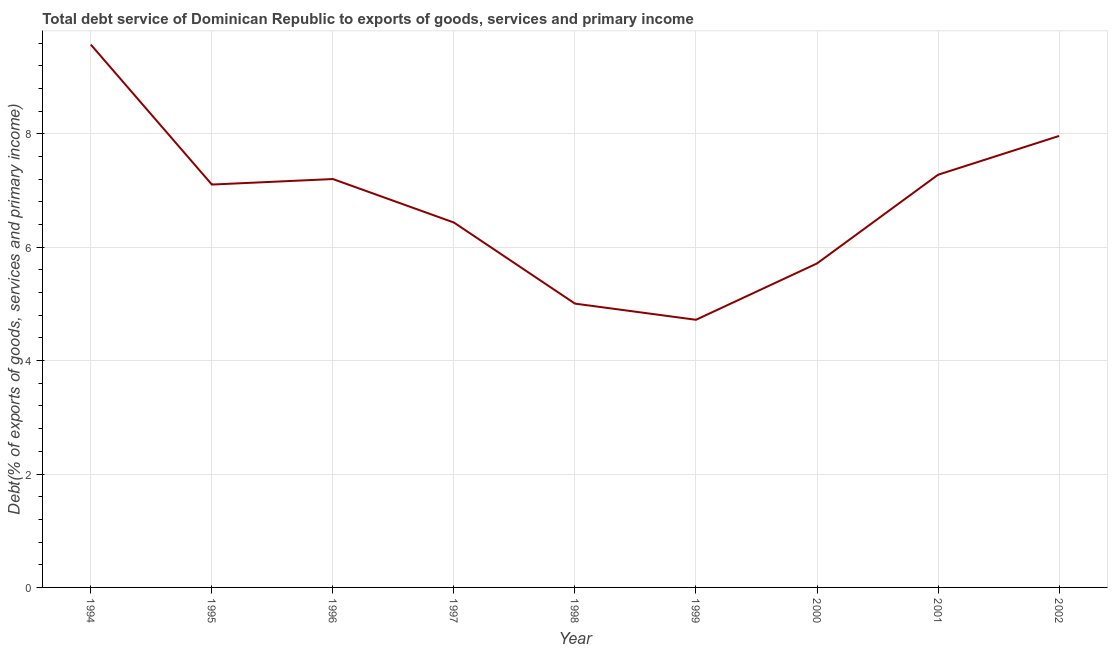What is the total debt service in 1997?
Make the answer very short. 6.43. Across all years, what is the maximum total debt service?
Make the answer very short. 9.57. Across all years, what is the minimum total debt service?
Offer a very short reply. 4.72. In which year was the total debt service maximum?
Your answer should be very brief. 1994. In which year was the total debt service minimum?
Your response must be concise. 1999. What is the sum of the total debt service?
Provide a short and direct response. 60.99. What is the difference between the total debt service in 1995 and 2002?
Ensure brevity in your answer.  -0.86. What is the average total debt service per year?
Provide a short and direct response. 6.78. What is the median total debt service?
Offer a very short reply. 7.1. In how many years, is the total debt service greater than 6.4 %?
Provide a short and direct response. 6. Do a majority of the years between 1995 and 1999 (inclusive) have total debt service greater than 6 %?
Ensure brevity in your answer.  Yes. What is the ratio of the total debt service in 1994 to that in 1996?
Offer a very short reply. 1.33. Is the difference between the total debt service in 1998 and 2002 greater than the difference between any two years?
Offer a very short reply. No. What is the difference between the highest and the second highest total debt service?
Your answer should be compact. 1.61. What is the difference between the highest and the lowest total debt service?
Make the answer very short. 4.85. Does the total debt service monotonically increase over the years?
Keep it short and to the point. No. How many years are there in the graph?
Offer a very short reply. 9. What is the difference between two consecutive major ticks on the Y-axis?
Your response must be concise. 2. Does the graph contain grids?
Provide a short and direct response. Yes. What is the title of the graph?
Your answer should be very brief. Total debt service of Dominican Republic to exports of goods, services and primary income. What is the label or title of the Y-axis?
Give a very brief answer. Debt(% of exports of goods, services and primary income). What is the Debt(% of exports of goods, services and primary income) in 1994?
Provide a succinct answer. 9.57. What is the Debt(% of exports of goods, services and primary income) of 1995?
Offer a terse response. 7.1. What is the Debt(% of exports of goods, services and primary income) in 1996?
Keep it short and to the point. 7.2. What is the Debt(% of exports of goods, services and primary income) of 1997?
Provide a succinct answer. 6.43. What is the Debt(% of exports of goods, services and primary income) in 1998?
Provide a short and direct response. 5. What is the Debt(% of exports of goods, services and primary income) of 1999?
Offer a terse response. 4.72. What is the Debt(% of exports of goods, services and primary income) of 2000?
Provide a short and direct response. 5.71. What is the Debt(% of exports of goods, services and primary income) in 2001?
Ensure brevity in your answer.  7.28. What is the Debt(% of exports of goods, services and primary income) of 2002?
Offer a terse response. 7.96. What is the difference between the Debt(% of exports of goods, services and primary income) in 1994 and 1995?
Offer a very short reply. 2.47. What is the difference between the Debt(% of exports of goods, services and primary income) in 1994 and 1996?
Give a very brief answer. 2.37. What is the difference between the Debt(% of exports of goods, services and primary income) in 1994 and 1997?
Your response must be concise. 3.14. What is the difference between the Debt(% of exports of goods, services and primary income) in 1994 and 1998?
Your answer should be very brief. 4.57. What is the difference between the Debt(% of exports of goods, services and primary income) in 1994 and 1999?
Provide a succinct answer. 4.85. What is the difference between the Debt(% of exports of goods, services and primary income) in 1994 and 2000?
Make the answer very short. 3.86. What is the difference between the Debt(% of exports of goods, services and primary income) in 1994 and 2001?
Your answer should be compact. 2.3. What is the difference between the Debt(% of exports of goods, services and primary income) in 1994 and 2002?
Make the answer very short. 1.61. What is the difference between the Debt(% of exports of goods, services and primary income) in 1995 and 1996?
Your answer should be very brief. -0.1. What is the difference between the Debt(% of exports of goods, services and primary income) in 1995 and 1997?
Your answer should be very brief. 0.67. What is the difference between the Debt(% of exports of goods, services and primary income) in 1995 and 1998?
Offer a terse response. 2.1. What is the difference between the Debt(% of exports of goods, services and primary income) in 1995 and 1999?
Ensure brevity in your answer.  2.38. What is the difference between the Debt(% of exports of goods, services and primary income) in 1995 and 2000?
Provide a succinct answer. 1.39. What is the difference between the Debt(% of exports of goods, services and primary income) in 1995 and 2001?
Provide a succinct answer. -0.17. What is the difference between the Debt(% of exports of goods, services and primary income) in 1995 and 2002?
Offer a terse response. -0.86. What is the difference between the Debt(% of exports of goods, services and primary income) in 1996 and 1997?
Your answer should be very brief. 0.77. What is the difference between the Debt(% of exports of goods, services and primary income) in 1996 and 1998?
Provide a succinct answer. 2.2. What is the difference between the Debt(% of exports of goods, services and primary income) in 1996 and 1999?
Your answer should be compact. 2.48. What is the difference between the Debt(% of exports of goods, services and primary income) in 1996 and 2000?
Offer a terse response. 1.49. What is the difference between the Debt(% of exports of goods, services and primary income) in 1996 and 2001?
Ensure brevity in your answer.  -0.08. What is the difference between the Debt(% of exports of goods, services and primary income) in 1996 and 2002?
Offer a terse response. -0.76. What is the difference between the Debt(% of exports of goods, services and primary income) in 1997 and 1998?
Provide a short and direct response. 1.43. What is the difference between the Debt(% of exports of goods, services and primary income) in 1997 and 1999?
Offer a terse response. 1.71. What is the difference between the Debt(% of exports of goods, services and primary income) in 1997 and 2000?
Your response must be concise. 0.72. What is the difference between the Debt(% of exports of goods, services and primary income) in 1997 and 2001?
Your response must be concise. -0.84. What is the difference between the Debt(% of exports of goods, services and primary income) in 1997 and 2002?
Make the answer very short. -1.53. What is the difference between the Debt(% of exports of goods, services and primary income) in 1998 and 1999?
Provide a short and direct response. 0.29. What is the difference between the Debt(% of exports of goods, services and primary income) in 1998 and 2000?
Ensure brevity in your answer.  -0.71. What is the difference between the Debt(% of exports of goods, services and primary income) in 1998 and 2001?
Provide a short and direct response. -2.27. What is the difference between the Debt(% of exports of goods, services and primary income) in 1998 and 2002?
Offer a very short reply. -2.96. What is the difference between the Debt(% of exports of goods, services and primary income) in 1999 and 2000?
Offer a very short reply. -0.99. What is the difference between the Debt(% of exports of goods, services and primary income) in 1999 and 2001?
Provide a succinct answer. -2.56. What is the difference between the Debt(% of exports of goods, services and primary income) in 1999 and 2002?
Offer a terse response. -3.24. What is the difference between the Debt(% of exports of goods, services and primary income) in 2000 and 2001?
Provide a succinct answer. -1.56. What is the difference between the Debt(% of exports of goods, services and primary income) in 2000 and 2002?
Offer a terse response. -2.25. What is the difference between the Debt(% of exports of goods, services and primary income) in 2001 and 2002?
Your response must be concise. -0.68. What is the ratio of the Debt(% of exports of goods, services and primary income) in 1994 to that in 1995?
Make the answer very short. 1.35. What is the ratio of the Debt(% of exports of goods, services and primary income) in 1994 to that in 1996?
Your answer should be very brief. 1.33. What is the ratio of the Debt(% of exports of goods, services and primary income) in 1994 to that in 1997?
Provide a succinct answer. 1.49. What is the ratio of the Debt(% of exports of goods, services and primary income) in 1994 to that in 1998?
Offer a terse response. 1.91. What is the ratio of the Debt(% of exports of goods, services and primary income) in 1994 to that in 1999?
Make the answer very short. 2.03. What is the ratio of the Debt(% of exports of goods, services and primary income) in 1994 to that in 2000?
Your response must be concise. 1.68. What is the ratio of the Debt(% of exports of goods, services and primary income) in 1994 to that in 2001?
Keep it short and to the point. 1.31. What is the ratio of the Debt(% of exports of goods, services and primary income) in 1994 to that in 2002?
Give a very brief answer. 1.2. What is the ratio of the Debt(% of exports of goods, services and primary income) in 1995 to that in 1996?
Make the answer very short. 0.99. What is the ratio of the Debt(% of exports of goods, services and primary income) in 1995 to that in 1997?
Offer a very short reply. 1.1. What is the ratio of the Debt(% of exports of goods, services and primary income) in 1995 to that in 1998?
Offer a very short reply. 1.42. What is the ratio of the Debt(% of exports of goods, services and primary income) in 1995 to that in 1999?
Ensure brevity in your answer.  1.5. What is the ratio of the Debt(% of exports of goods, services and primary income) in 1995 to that in 2000?
Offer a terse response. 1.24. What is the ratio of the Debt(% of exports of goods, services and primary income) in 1995 to that in 2001?
Provide a succinct answer. 0.98. What is the ratio of the Debt(% of exports of goods, services and primary income) in 1995 to that in 2002?
Offer a very short reply. 0.89. What is the ratio of the Debt(% of exports of goods, services and primary income) in 1996 to that in 1997?
Provide a succinct answer. 1.12. What is the ratio of the Debt(% of exports of goods, services and primary income) in 1996 to that in 1998?
Ensure brevity in your answer.  1.44. What is the ratio of the Debt(% of exports of goods, services and primary income) in 1996 to that in 1999?
Offer a terse response. 1.53. What is the ratio of the Debt(% of exports of goods, services and primary income) in 1996 to that in 2000?
Provide a short and direct response. 1.26. What is the ratio of the Debt(% of exports of goods, services and primary income) in 1996 to that in 2001?
Give a very brief answer. 0.99. What is the ratio of the Debt(% of exports of goods, services and primary income) in 1996 to that in 2002?
Your answer should be compact. 0.91. What is the ratio of the Debt(% of exports of goods, services and primary income) in 1997 to that in 1998?
Your response must be concise. 1.29. What is the ratio of the Debt(% of exports of goods, services and primary income) in 1997 to that in 1999?
Your response must be concise. 1.36. What is the ratio of the Debt(% of exports of goods, services and primary income) in 1997 to that in 2000?
Offer a terse response. 1.13. What is the ratio of the Debt(% of exports of goods, services and primary income) in 1997 to that in 2001?
Your answer should be very brief. 0.88. What is the ratio of the Debt(% of exports of goods, services and primary income) in 1997 to that in 2002?
Ensure brevity in your answer.  0.81. What is the ratio of the Debt(% of exports of goods, services and primary income) in 1998 to that in 1999?
Your answer should be compact. 1.06. What is the ratio of the Debt(% of exports of goods, services and primary income) in 1998 to that in 2000?
Your answer should be compact. 0.88. What is the ratio of the Debt(% of exports of goods, services and primary income) in 1998 to that in 2001?
Ensure brevity in your answer.  0.69. What is the ratio of the Debt(% of exports of goods, services and primary income) in 1998 to that in 2002?
Your answer should be compact. 0.63. What is the ratio of the Debt(% of exports of goods, services and primary income) in 1999 to that in 2000?
Your answer should be very brief. 0.83. What is the ratio of the Debt(% of exports of goods, services and primary income) in 1999 to that in 2001?
Provide a succinct answer. 0.65. What is the ratio of the Debt(% of exports of goods, services and primary income) in 1999 to that in 2002?
Ensure brevity in your answer.  0.59. What is the ratio of the Debt(% of exports of goods, services and primary income) in 2000 to that in 2001?
Your answer should be compact. 0.79. What is the ratio of the Debt(% of exports of goods, services and primary income) in 2000 to that in 2002?
Your answer should be compact. 0.72. What is the ratio of the Debt(% of exports of goods, services and primary income) in 2001 to that in 2002?
Give a very brief answer. 0.91. 